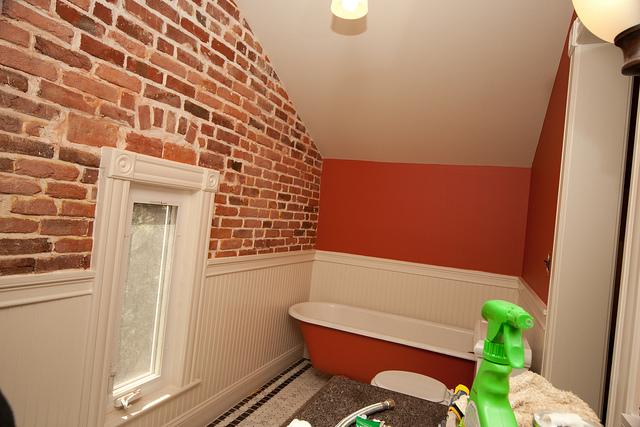What color is inside the tub?
Short answer required. White. What part of the room is the bathtub painted to match?
Be succinct. Wall. What is the green object?
Short answer required. Spray bottle. Is the window open?
Quick response, please. No. 